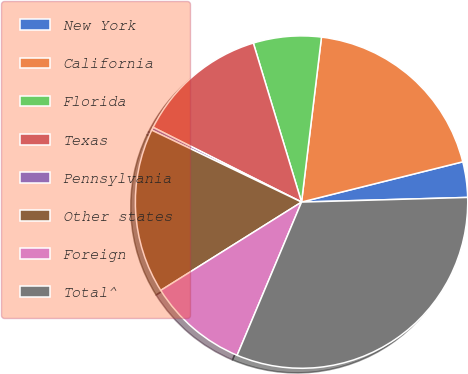Convert chart. <chart><loc_0><loc_0><loc_500><loc_500><pie_chart><fcel>New York<fcel>California<fcel>Florida<fcel>Texas<fcel>Pennsylvania<fcel>Other states<fcel>Foreign<fcel>Total^<nl><fcel>3.45%<fcel>19.19%<fcel>6.6%<fcel>12.89%<fcel>0.3%<fcel>16.04%<fcel>9.75%<fcel>31.78%<nl></chart> 